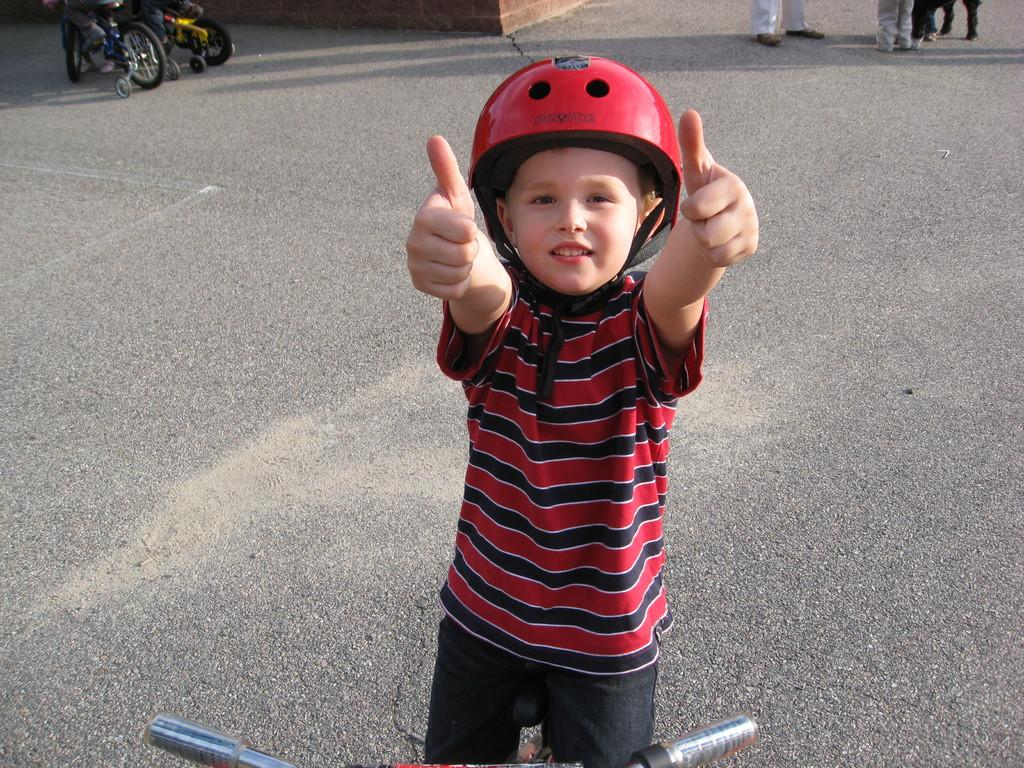What is the main subject of the image? The main subject of the image is a kid. What is the kid wearing in the image? The kid is wearing a red dress and a helmet. Where is the kid standing in the image? The kid is standing on the road. What type of cakes is the kid pulling in the image? There are no cakes present in the image, and the kid is not pulling anything. 